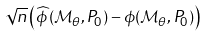<formula> <loc_0><loc_0><loc_500><loc_500>\sqrt { n } \left ( \widehat { \phi } \left ( \mathcal { M } _ { \theta } , P _ { 0 } \right ) - \phi ( \mathcal { M } _ { \theta } , P _ { 0 } ) \right )</formula> 